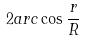Convert formula to latex. <formula><loc_0><loc_0><loc_500><loc_500>2 a r c \cos \frac { r } { R }</formula> 